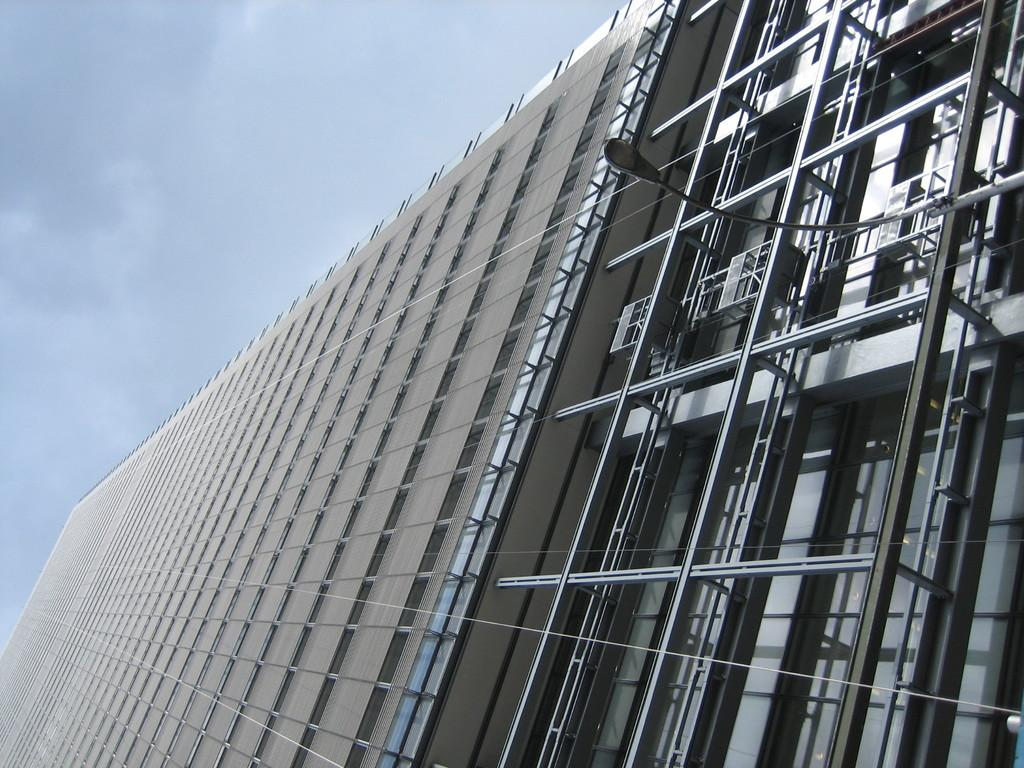What type of structure is present in the image? There is a building in the image. What can be seen above the building in the image? The sky is visible at the top of the image. What decision did the father make in the image? There is no father or decision-making process depicted in the image. 